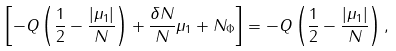Convert formula to latex. <formula><loc_0><loc_0><loc_500><loc_500>\left [ - Q \left ( \frac { 1 } { 2 } - \frac { | \mu _ { 1 } | } { N } \right ) + \frac { \delta N } { N } \mu _ { 1 } + N _ { \Phi } \right ] = - Q \left ( \frac { 1 } { 2 } - \frac { | \mu _ { 1 } | } { N } \right ) ,</formula> 